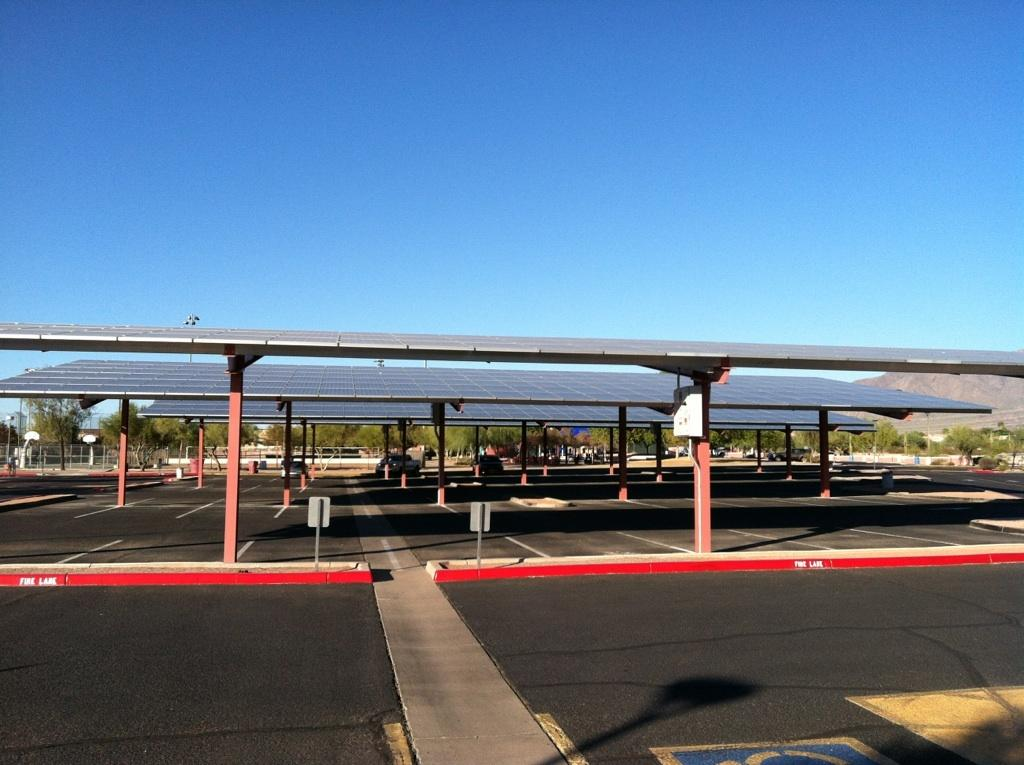What type of road is depicted in the image? The image contains a freeway. What can be seen on top of some buildings in the image? There are white roofs in the image. What type of natural feature is visible in the background of the image? There are trees in the background of the image. How many hydrants are visible in the image? There are no hydrants present in the image. What type of animal is marking its territory in the image? There are no animals or territories depicted in the image. 